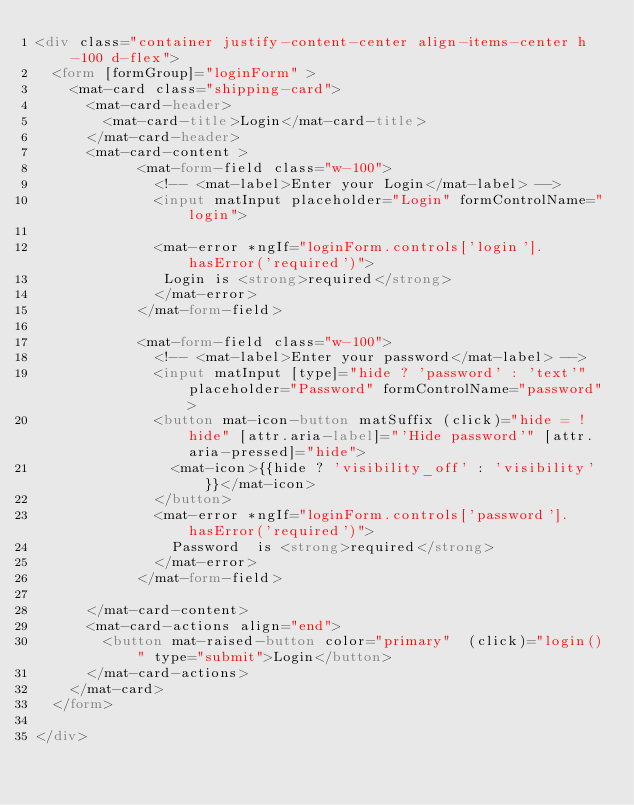Convert code to text. <code><loc_0><loc_0><loc_500><loc_500><_HTML_><div class="container justify-content-center align-items-center h-100 d-flex">
  <form [formGroup]="loginForm" >
    <mat-card class="shipping-card">
      <mat-card-header>
        <mat-card-title>Login</mat-card-title>
      </mat-card-header>
      <mat-card-content >
            <mat-form-field class="w-100">
              <!-- <mat-label>Enter your Login</mat-label> -->
              <input matInput placeholder="Login" formControlName="login">
              
              <mat-error *ngIf="loginForm.controls['login'].hasError('required')">
               Login is <strong>required</strong>
              </mat-error>
            </mat-form-field>
         
            <mat-form-field class="w-100">
              <!-- <mat-label>Enter your password</mat-label> -->
              <input matInput [type]="hide ? 'password' : 'text'" placeholder="Password" formControlName="password">
              <button mat-icon-button matSuffix (click)="hide = !hide" [attr.aria-label]="'Hide password'" [attr.aria-pressed]="hide">
                <mat-icon>{{hide ? 'visibility_off' : 'visibility'}}</mat-icon>
              </button>
              <mat-error *ngIf="loginForm.controls['password'].hasError('required')">
                Password  is <strong>required</strong>
              </mat-error>
            </mat-form-field>

      </mat-card-content>
      <mat-card-actions align="end">
        <button mat-raised-button color="primary"  (click)="login()" type="submit">Login</button>
      </mat-card-actions>
    </mat-card>
  </form>
  
</div></code> 